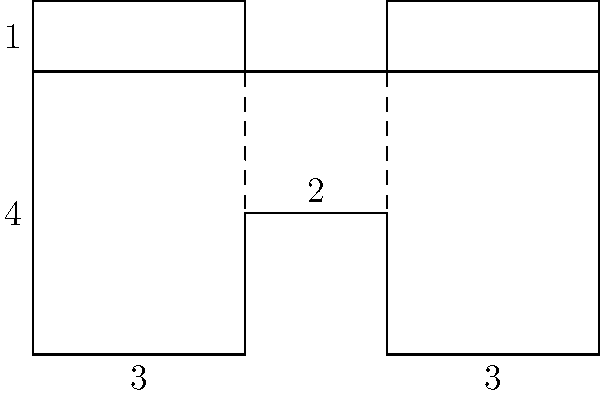Given the unfolded packaging design shown above, what is the volume (in cubic units) of the assembled box? To find the volume of the assembled box, we need to follow these steps:

1. Identify the dimensions of the box:
   - Length: The bottom panel is divided into three sections of 3, 2, and 3 units. The total length is 3 + 2 + 3 = 8 units.
   - Width: The side panels are 4 units tall.
   - Height: The front and back panels are 3 units wide.

2. Calculate the volume using the formula:
   $$ V = l \times w \times h $$
   Where:
   $l$ = length
   $w$ = width
   $h$ = height

3. Substitute the values:
   $$ V = 8 \times 4 \times 3 $$

4. Compute the final result:
   $$ V = 96 \text{ cubic units} $$

Therefore, the volume of the assembled box is 96 cubic units.
Answer: 96 cubic units 